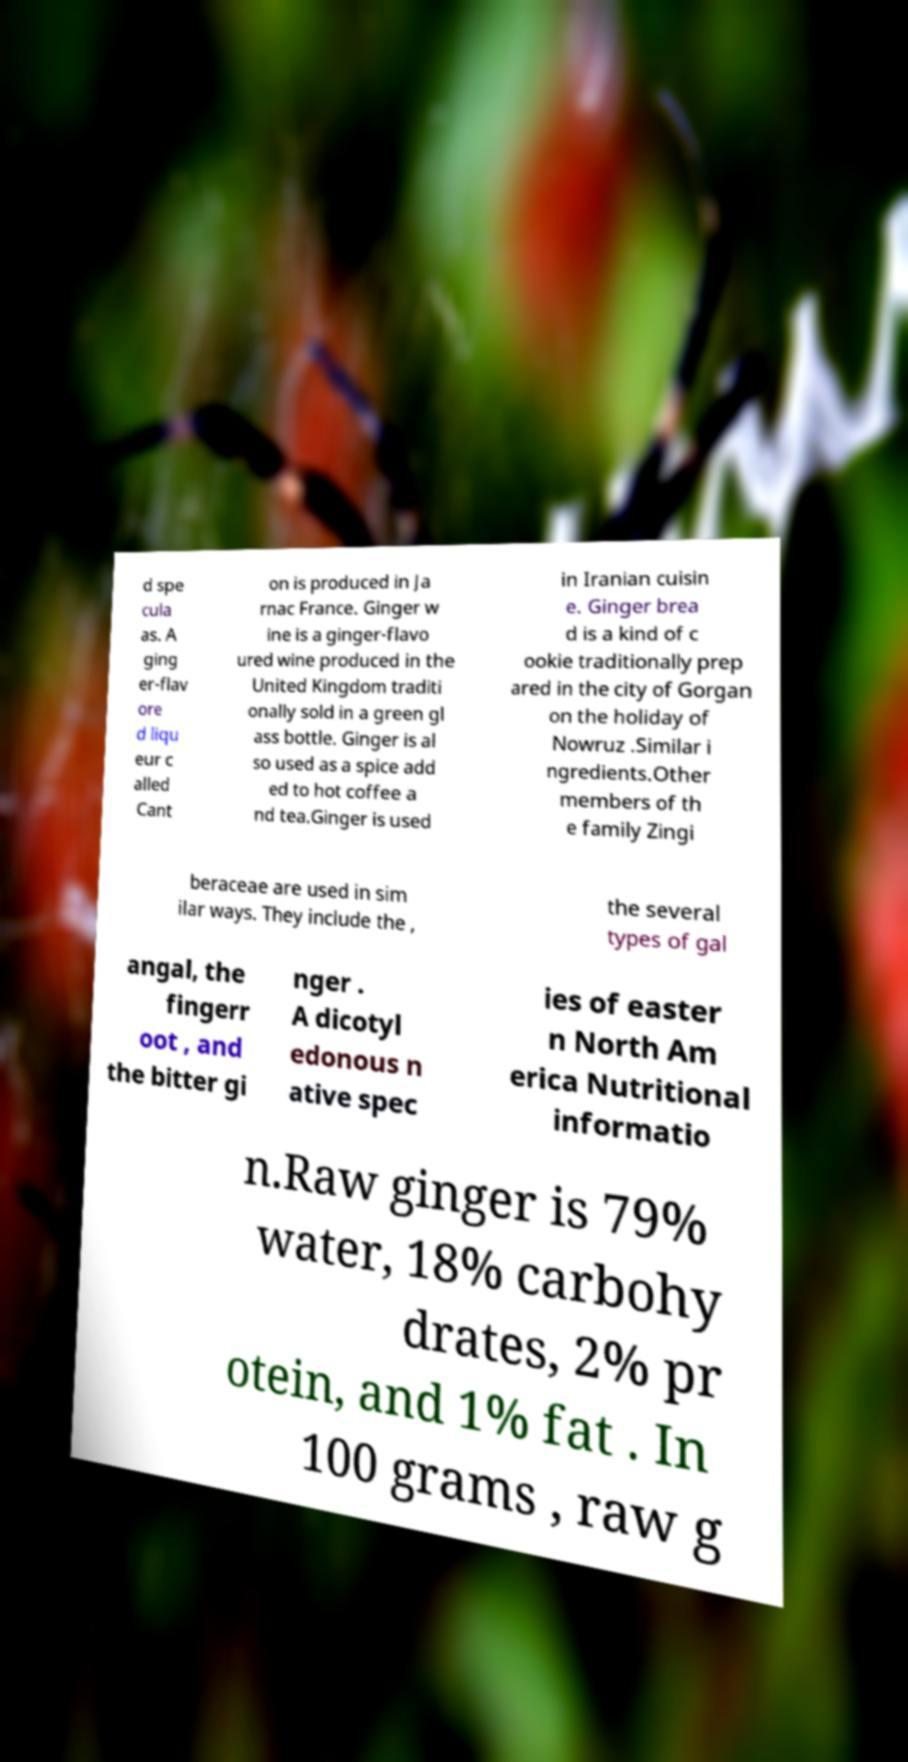There's text embedded in this image that I need extracted. Can you transcribe it verbatim? d spe cula as. A ging er-flav ore d liqu eur c alled Cant on is produced in Ja rnac France. Ginger w ine is a ginger-flavo ured wine produced in the United Kingdom traditi onally sold in a green gl ass bottle. Ginger is al so used as a spice add ed to hot coffee a nd tea.Ginger is used in Iranian cuisin e. Ginger brea d is a kind of c ookie traditionally prep ared in the city of Gorgan on the holiday of Nowruz .Similar i ngredients.Other members of th e family Zingi beraceae are used in sim ilar ways. They include the , the several types of gal angal, the fingerr oot , and the bitter gi nger . A dicotyl edonous n ative spec ies of easter n North Am erica Nutritional informatio n.Raw ginger is 79% water, 18% carbohy drates, 2% pr otein, and 1% fat . In 100 grams , raw g 